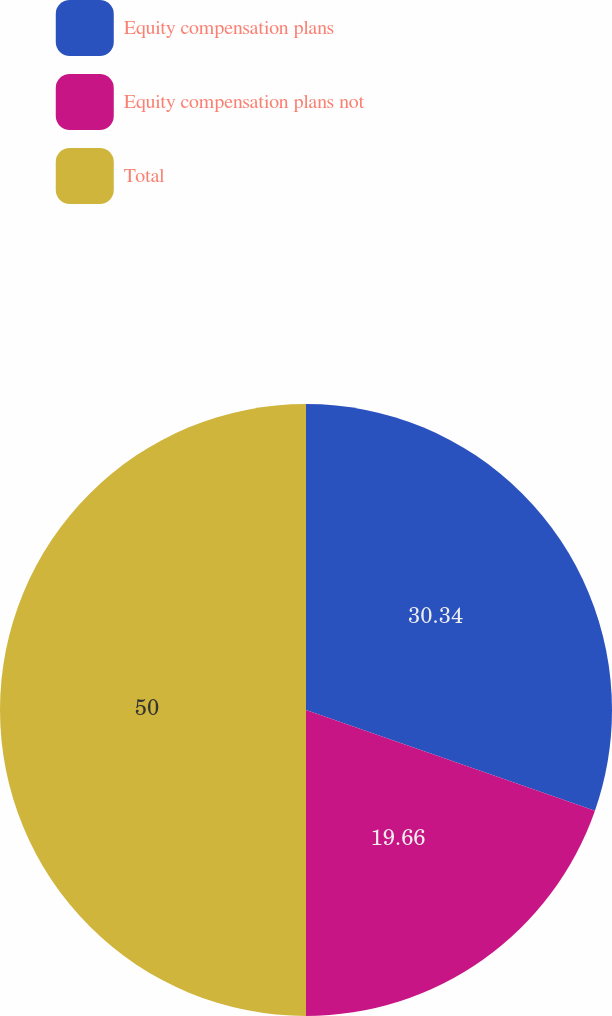<chart> <loc_0><loc_0><loc_500><loc_500><pie_chart><fcel>Equity compensation plans<fcel>Equity compensation plans not<fcel>Total<nl><fcel>30.34%<fcel>19.66%<fcel>50.0%<nl></chart> 